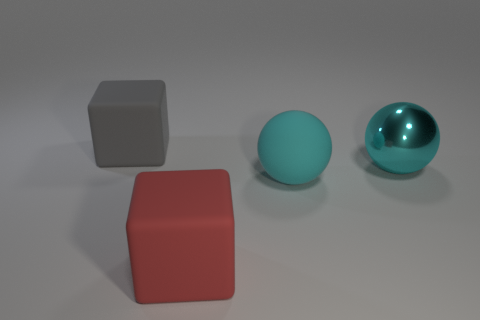Add 2 red matte blocks. How many objects exist? 6 Subtract all gray cubes. How many cubes are left? 1 Subtract 1 balls. How many balls are left? 1 Subtract all gray cubes. Subtract all purple balls. How many cubes are left? 1 Add 1 big gray rubber objects. How many big gray rubber objects are left? 2 Add 2 red rubber things. How many red rubber things exist? 3 Subtract 1 gray blocks. How many objects are left? 3 Subtract all tiny gray rubber objects. Subtract all big matte spheres. How many objects are left? 3 